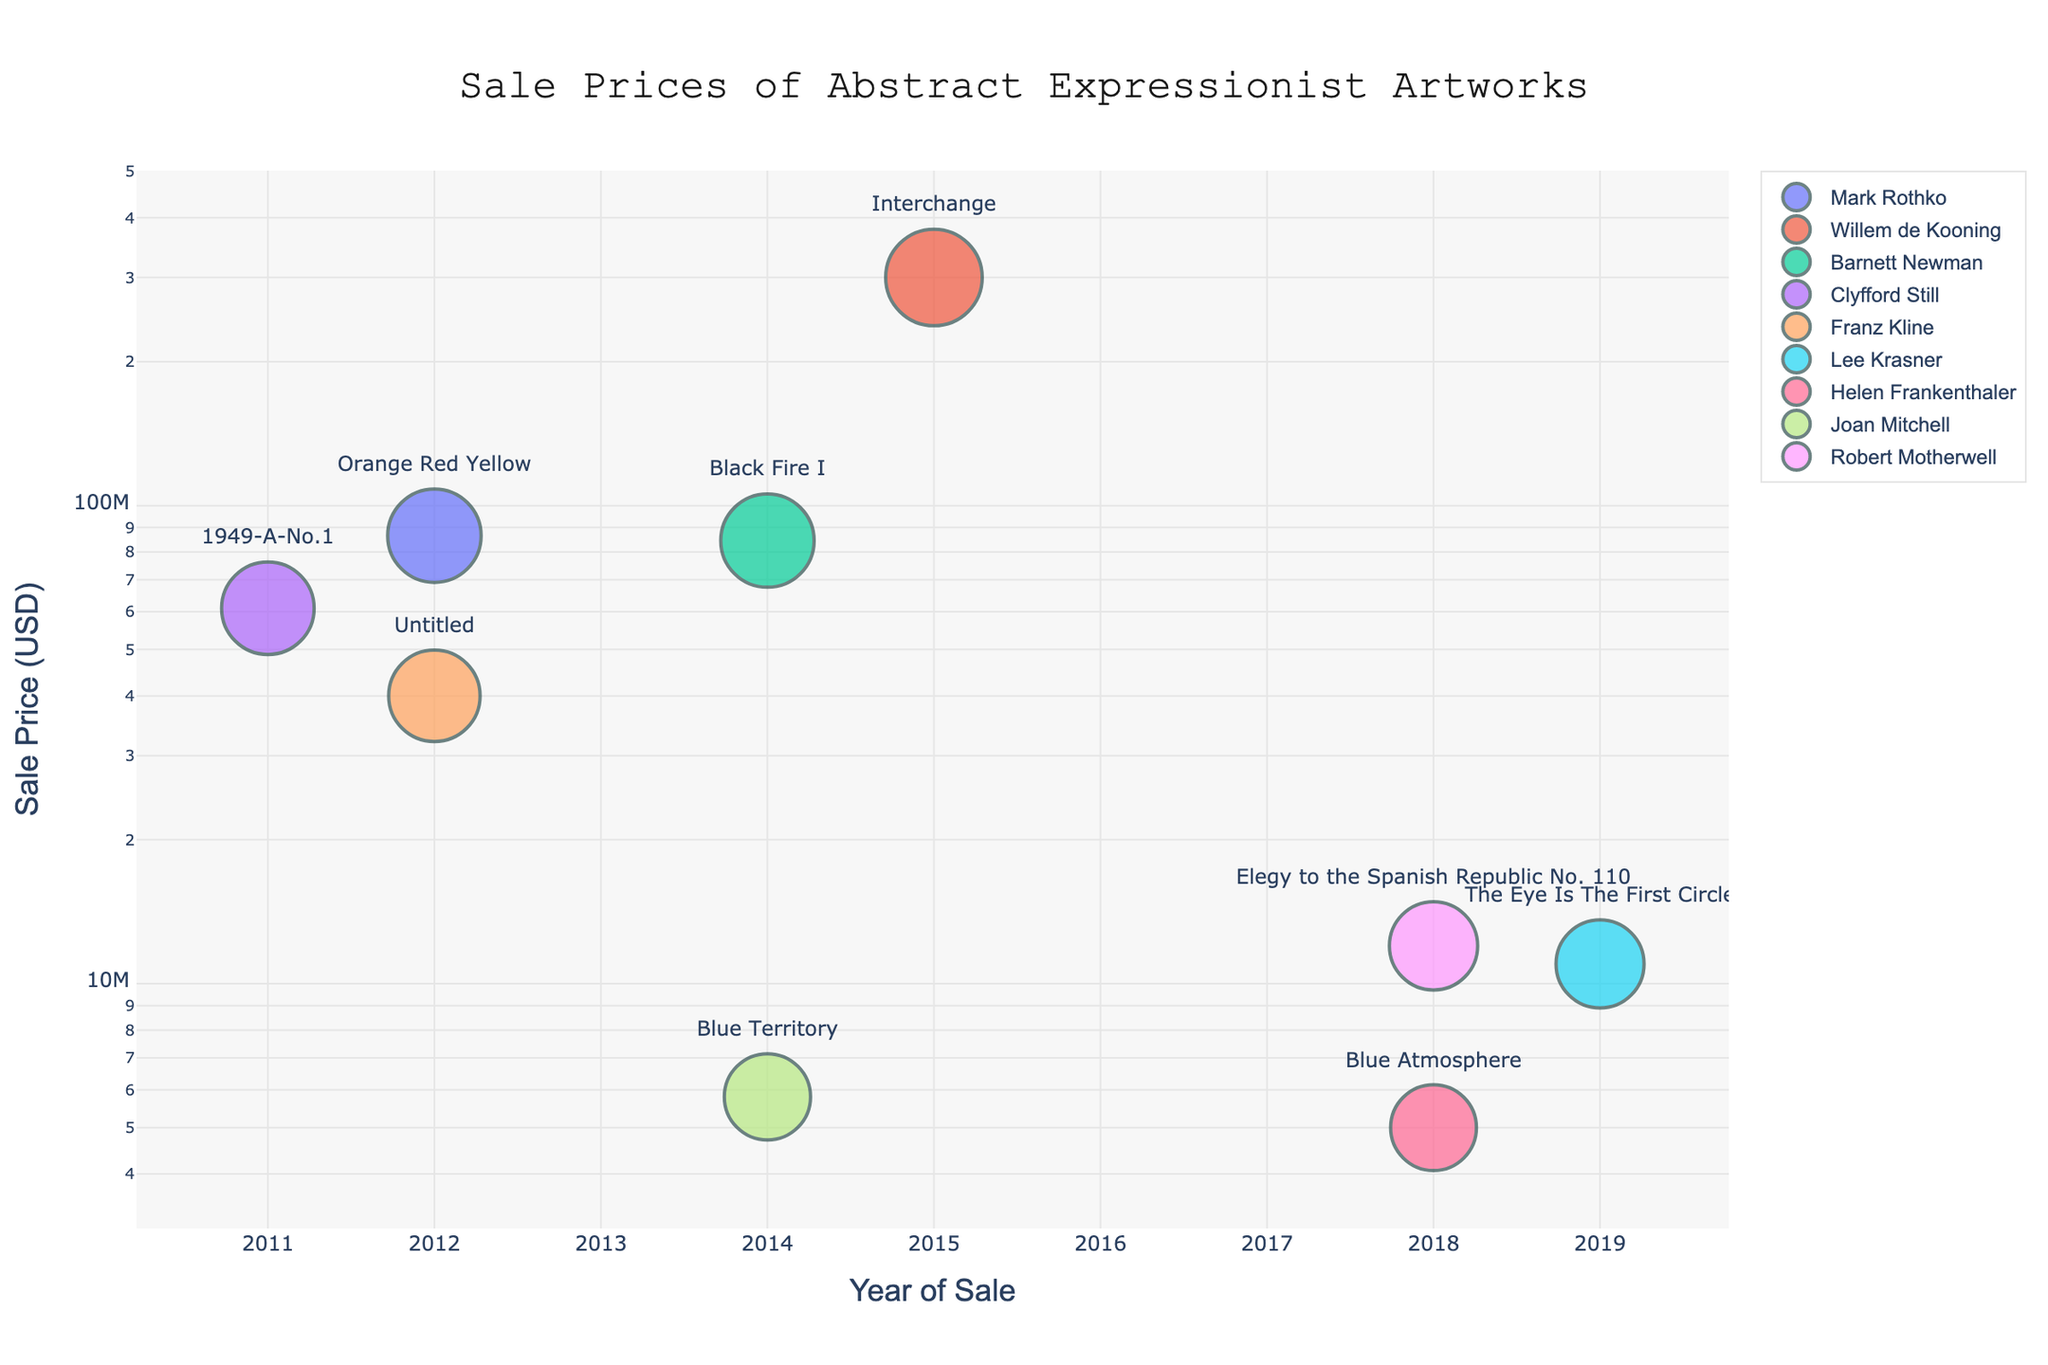who is the artist of the artwork sold for the highest price? The highest price point on the scatter plot corresponds to the artwork "Interchange," which belongs to the artist Willem de Kooning.
Answer: Willem de Kooning What's the range of years covered by the sales data? The earliest year on the x-axis is 2011, and the latest year is 2019. The range is from 2011 to 2019.
Answer: 2011 to 2019 How many artworks were sold for $50,000,000 or more? By examining the y-axis on a log scale, the points above $50,000,000 are for the artworks by Mark Rothko, Willem de Kooning, Barnett Newman, and Clyfford Still. Counting these gives four artworks.
Answer: 4 Which artist has the most number of artworks sold in this dataset? By counting the number of markers for each artist, Joan Mitchell, Willem de Kooning, Barnett Newman, Clyfford Still, Franz Kline, Lee Krasner, Helen Frankenthaler, and Robert Motherwell all have 1 artwork, while Joan Mitchell has 2.
Answer: Joan Mitchell What's the median sale price of the artworks? Sorting the sale prices: 5,000,000; 5,800,000; 11,000,000; 12,000,000; 40,000,000; 61,000,000; 84,500,000; 86,500,000, and 300,000,000. The middle value is 40,000,000 as it's the fifth value in a list with nine items.
Answer: 40,000,000 Which artwork by Barnett Newman was sold, and in which year? The plot highlights "Black Fire I" when pointing to Barnett Newman's marker, indicating it was sold in 2014.
Answer: Black Fire I, 2014 Between 2012 and 2014, which artist had the highest sale price? For the years 2012 to 2014, Mark Rothko's "Orange Red Yellow" sold for 86,500,000 in 2012, which is higher than any other prices in this range.
Answer: Mark Rothko What is the difference in sale price between the most expensive and the least expensive artwork? The most expensive artwork sold for 300,000,000, and the least expensive sold for 5,000,000. The difference is 300,000,000 - 5,000,000 = 295,000,000.
Answer: 295,000,000 Which artists' works were sold in 2018, and what were their prices? In 2018, Helen Frankenthaler's "Blue Atmosphere" sold for 5,000,000 and Robert Motherwell's "Elegy to the Spanish Republic No. 110" sold for 12,000,000.
Answer: Helen Frankenthaler (5,000,000), Robert Motherwell (12,000,000) Are there any years without any artworks sold in this dataset? Examining the x-axis, there are no data points for the year 2013, indicating no artworks were sold in that year as per this dataset.
Answer: 2013 